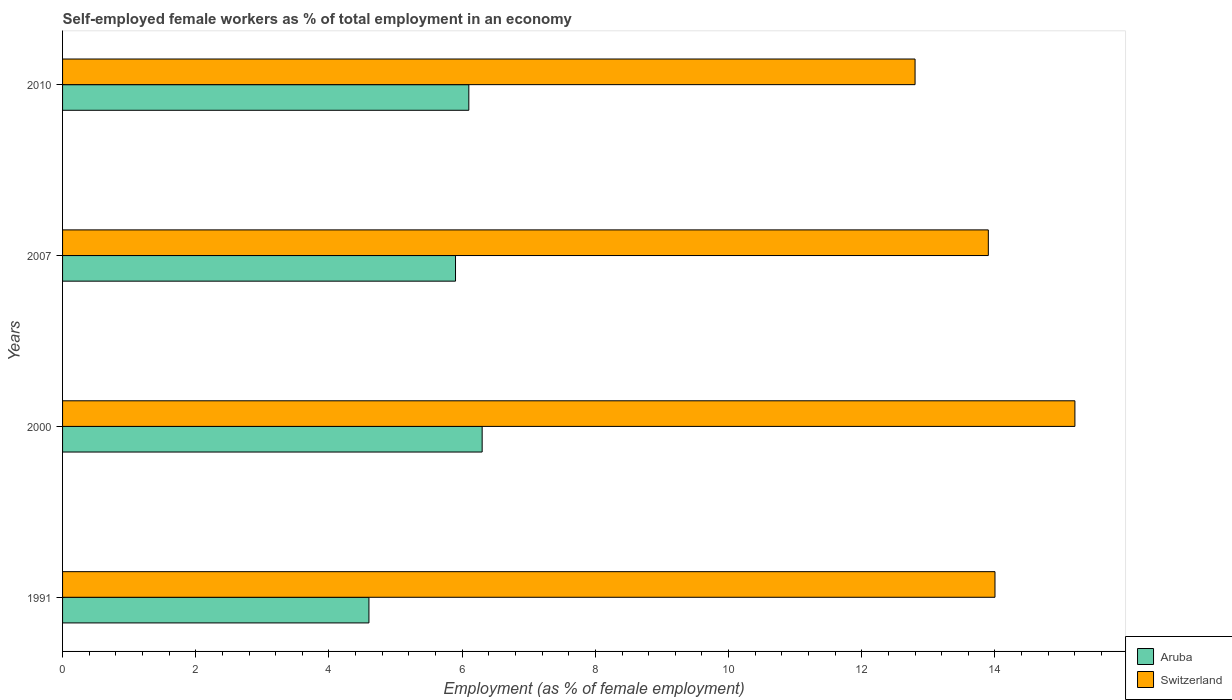Are the number of bars per tick equal to the number of legend labels?
Keep it short and to the point. Yes. Are the number of bars on each tick of the Y-axis equal?
Your response must be concise. Yes. How many bars are there on the 3rd tick from the top?
Provide a short and direct response. 2. How many bars are there on the 1st tick from the bottom?
Give a very brief answer. 2. What is the percentage of self-employed female workers in Switzerland in 2010?
Offer a terse response. 12.8. Across all years, what is the maximum percentage of self-employed female workers in Switzerland?
Provide a succinct answer. 15.2. Across all years, what is the minimum percentage of self-employed female workers in Aruba?
Make the answer very short. 4.6. In which year was the percentage of self-employed female workers in Switzerland maximum?
Keep it short and to the point. 2000. What is the total percentage of self-employed female workers in Switzerland in the graph?
Your response must be concise. 55.9. What is the difference between the percentage of self-employed female workers in Switzerland in 2000 and that in 2007?
Your answer should be very brief. 1.3. What is the difference between the percentage of self-employed female workers in Aruba in 2000 and the percentage of self-employed female workers in Switzerland in 2007?
Provide a succinct answer. -7.6. What is the average percentage of self-employed female workers in Switzerland per year?
Keep it short and to the point. 13.97. In the year 1991, what is the difference between the percentage of self-employed female workers in Switzerland and percentage of self-employed female workers in Aruba?
Offer a terse response. 9.4. What is the ratio of the percentage of self-employed female workers in Switzerland in 2000 to that in 2010?
Ensure brevity in your answer.  1.19. What is the difference between the highest and the second highest percentage of self-employed female workers in Switzerland?
Keep it short and to the point. 1.2. What is the difference between the highest and the lowest percentage of self-employed female workers in Switzerland?
Keep it short and to the point. 2.4. Is the sum of the percentage of self-employed female workers in Switzerland in 2007 and 2010 greater than the maximum percentage of self-employed female workers in Aruba across all years?
Your response must be concise. Yes. What does the 2nd bar from the top in 1991 represents?
Give a very brief answer. Aruba. What does the 1st bar from the bottom in 2007 represents?
Give a very brief answer. Aruba. Are the values on the major ticks of X-axis written in scientific E-notation?
Your response must be concise. No. Does the graph contain any zero values?
Your response must be concise. No. Where does the legend appear in the graph?
Give a very brief answer. Bottom right. How many legend labels are there?
Offer a very short reply. 2. What is the title of the graph?
Provide a short and direct response. Self-employed female workers as % of total employment in an economy. What is the label or title of the X-axis?
Keep it short and to the point. Employment (as % of female employment). What is the label or title of the Y-axis?
Your response must be concise. Years. What is the Employment (as % of female employment) of Aruba in 1991?
Your answer should be compact. 4.6. What is the Employment (as % of female employment) in Switzerland in 1991?
Offer a very short reply. 14. What is the Employment (as % of female employment) of Aruba in 2000?
Provide a short and direct response. 6.3. What is the Employment (as % of female employment) of Switzerland in 2000?
Your answer should be very brief. 15.2. What is the Employment (as % of female employment) in Aruba in 2007?
Offer a terse response. 5.9. What is the Employment (as % of female employment) of Switzerland in 2007?
Make the answer very short. 13.9. What is the Employment (as % of female employment) in Aruba in 2010?
Your answer should be very brief. 6.1. What is the Employment (as % of female employment) in Switzerland in 2010?
Make the answer very short. 12.8. Across all years, what is the maximum Employment (as % of female employment) of Aruba?
Keep it short and to the point. 6.3. Across all years, what is the maximum Employment (as % of female employment) in Switzerland?
Keep it short and to the point. 15.2. Across all years, what is the minimum Employment (as % of female employment) in Aruba?
Ensure brevity in your answer.  4.6. Across all years, what is the minimum Employment (as % of female employment) in Switzerland?
Make the answer very short. 12.8. What is the total Employment (as % of female employment) in Aruba in the graph?
Ensure brevity in your answer.  22.9. What is the total Employment (as % of female employment) in Switzerland in the graph?
Keep it short and to the point. 55.9. What is the difference between the Employment (as % of female employment) in Aruba in 1991 and that in 2000?
Your answer should be very brief. -1.7. What is the difference between the Employment (as % of female employment) of Switzerland in 1991 and that in 2000?
Make the answer very short. -1.2. What is the difference between the Employment (as % of female employment) in Aruba in 1991 and that in 2007?
Provide a succinct answer. -1.3. What is the difference between the Employment (as % of female employment) in Aruba in 1991 and that in 2010?
Provide a succinct answer. -1.5. What is the difference between the Employment (as % of female employment) of Aruba in 2000 and that in 2007?
Ensure brevity in your answer.  0.4. What is the difference between the Employment (as % of female employment) in Switzerland in 2000 and that in 2007?
Provide a short and direct response. 1.3. What is the difference between the Employment (as % of female employment) of Aruba in 2000 and that in 2010?
Give a very brief answer. 0.2. What is the difference between the Employment (as % of female employment) in Switzerland in 2000 and that in 2010?
Your response must be concise. 2.4. What is the difference between the Employment (as % of female employment) of Aruba in 1991 and the Employment (as % of female employment) of Switzerland in 2000?
Offer a very short reply. -10.6. What is the difference between the Employment (as % of female employment) in Aruba in 1991 and the Employment (as % of female employment) in Switzerland in 2007?
Give a very brief answer. -9.3. What is the difference between the Employment (as % of female employment) of Aruba in 2007 and the Employment (as % of female employment) of Switzerland in 2010?
Your answer should be compact. -6.9. What is the average Employment (as % of female employment) in Aruba per year?
Give a very brief answer. 5.72. What is the average Employment (as % of female employment) of Switzerland per year?
Make the answer very short. 13.97. In the year 2000, what is the difference between the Employment (as % of female employment) of Aruba and Employment (as % of female employment) of Switzerland?
Your answer should be compact. -8.9. In the year 2007, what is the difference between the Employment (as % of female employment) of Aruba and Employment (as % of female employment) of Switzerland?
Keep it short and to the point. -8. What is the ratio of the Employment (as % of female employment) of Aruba in 1991 to that in 2000?
Provide a succinct answer. 0.73. What is the ratio of the Employment (as % of female employment) of Switzerland in 1991 to that in 2000?
Offer a terse response. 0.92. What is the ratio of the Employment (as % of female employment) of Aruba in 1991 to that in 2007?
Provide a short and direct response. 0.78. What is the ratio of the Employment (as % of female employment) of Switzerland in 1991 to that in 2007?
Your answer should be compact. 1.01. What is the ratio of the Employment (as % of female employment) in Aruba in 1991 to that in 2010?
Your answer should be very brief. 0.75. What is the ratio of the Employment (as % of female employment) of Switzerland in 1991 to that in 2010?
Your response must be concise. 1.09. What is the ratio of the Employment (as % of female employment) in Aruba in 2000 to that in 2007?
Give a very brief answer. 1.07. What is the ratio of the Employment (as % of female employment) in Switzerland in 2000 to that in 2007?
Offer a terse response. 1.09. What is the ratio of the Employment (as % of female employment) of Aruba in 2000 to that in 2010?
Your answer should be very brief. 1.03. What is the ratio of the Employment (as % of female employment) in Switzerland in 2000 to that in 2010?
Give a very brief answer. 1.19. What is the ratio of the Employment (as % of female employment) in Aruba in 2007 to that in 2010?
Offer a terse response. 0.97. What is the ratio of the Employment (as % of female employment) in Switzerland in 2007 to that in 2010?
Offer a very short reply. 1.09. What is the difference between the highest and the second highest Employment (as % of female employment) in Switzerland?
Give a very brief answer. 1.2. 